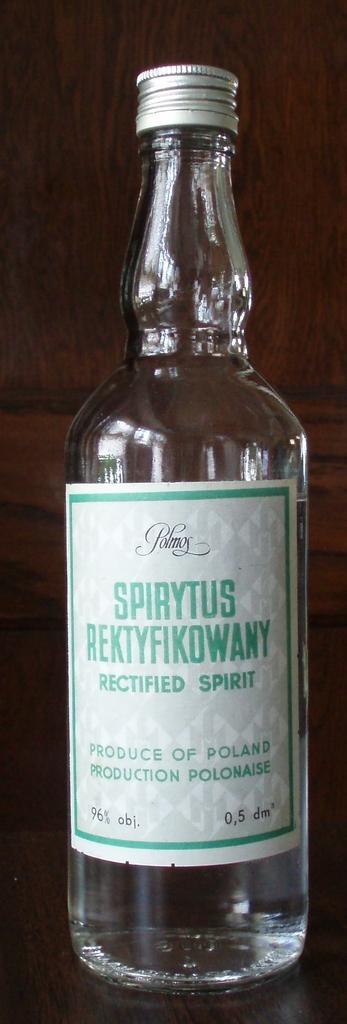What brand of alcohol is thi?
Ensure brevity in your answer.  Spirytus rektyfikowany. What volume of alcohol fits in this bottle?
Your response must be concise. 96%. 